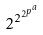<formula> <loc_0><loc_0><loc_500><loc_500>2 ^ { 2 ^ { 2 ^ { p ^ { a } } } }</formula> 